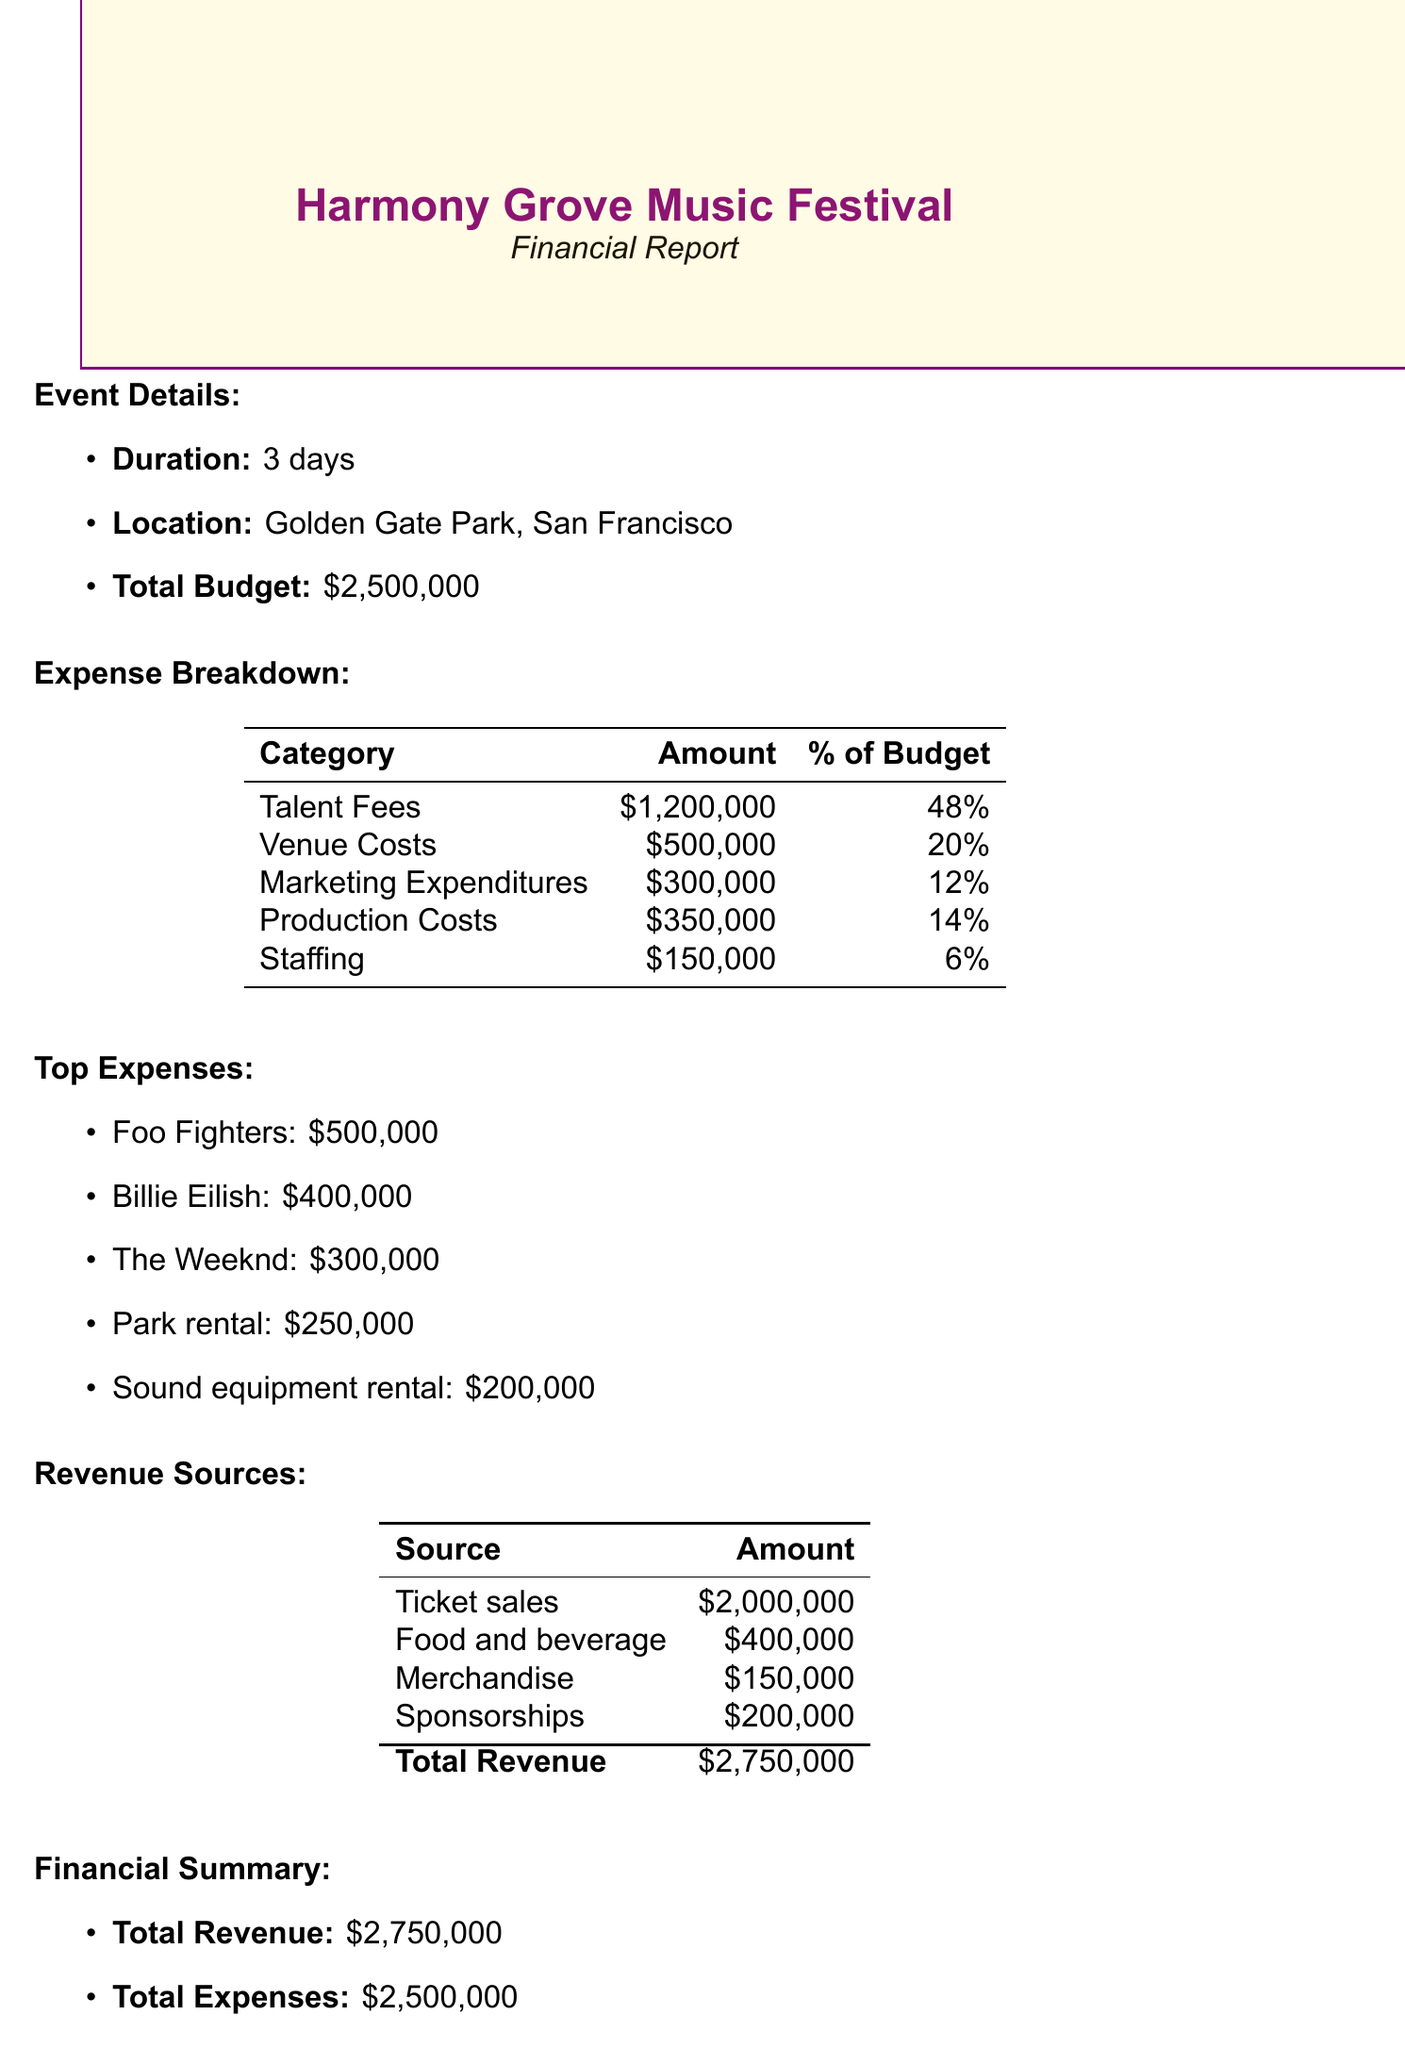What is the total budget? The total budget is explicitly stated in the document as $2,500,000.
Answer: $2,500,000 How much was spent on Talent Fees? The document provides a total amount for Talent Fees, which is $1,200,000.
Answer: $1,200,000 What is the cost of Park rental? The breakdown of Venue Costs specifies that Park rental costs $250,000.
Answer: $250,000 Which artist received the highest fee? The top expenses indicate that the Foo Fighters received the highest fee of $500,000.
Answer: Foo Fighters What percentage of the budget was spent on Marketing Expenditures? The expense table shows that Marketing Expenditures account for 12% of the total budget.
Answer: 12% What is the total revenue? The total revenue is calculated from all revenue sources listed in the document, amounting to $2,750,000.
Answer: $2,750,000 What are the total Production Costs? The document lists the total Production Costs as $350,000.
Answer: $350,000 How much profit was made after the festival? The Financial Summary states that the profit made is $250,000.
Answer: $250,000 What amount was allocated for Staffing? The document indicates that the total amount allocated for Staffing is $150,000.
Answer: $150,000 